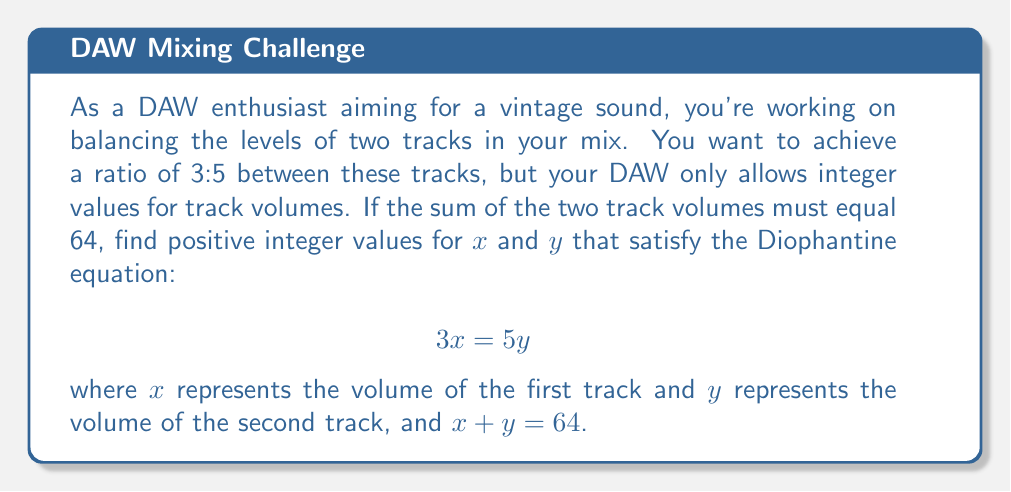Give your solution to this math problem. To solve this Diophantine equation while satisfying the given conditions, we'll follow these steps:

1) We have two equations:
   $$3x = 5y$$ (Equation 1)
   $$x + y = 64$$ (Equation 2)

2) From Equation 1, we can say that x must be divisible by 5, and y must be divisible by 3.
   Let x = 5k and y = 3k, where k is some integer.

3) Substituting these into Equation 2:
   $$5k + 3k = 64$$
   $$8k = 64$$
   $$k = 8$$

4) Now we can find x and y:
   $$x = 5k = 5(8) = 40$$
   $$y = 3k = 3(8) = 24$$

5) Let's verify:
   - Does 3x = 5y? Yes, 3(40) = 5(24) = 120
   - Does x + y = 64? Yes, 40 + 24 = 64
   - Are x and y positive integers? Yes

6) In the context of audio mixing, this means:
   - The volume of the first track should be set to 40
   - The volume of the second track should be set to 24
   - This achieves the desired 3:5 ratio (as 40:24 simplifies to 5:3)
   - The sum of the volumes is 64, as required
Answer: x = 40, y = 24 